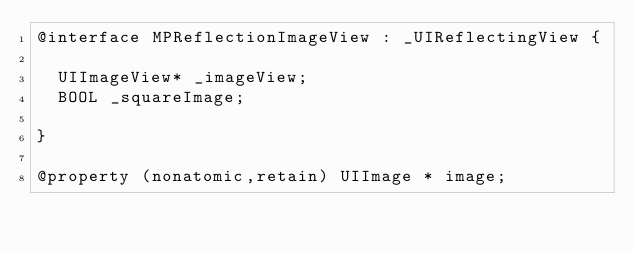Convert code to text. <code><loc_0><loc_0><loc_500><loc_500><_C_>@interface MPReflectionImageView : _UIReflectingView {

	UIImageView* _imageView;
	BOOL _squareImage;

}

@property (nonatomic,retain) UIImage * image; </code> 